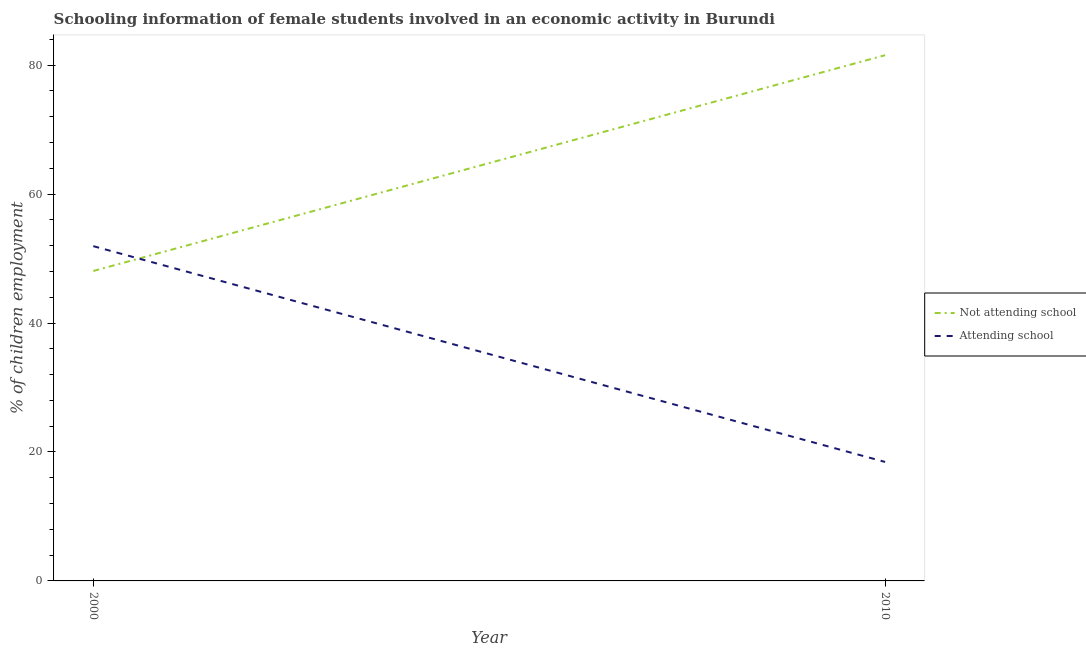How many different coloured lines are there?
Provide a succinct answer. 2. Does the line corresponding to percentage of employed females who are attending school intersect with the line corresponding to percentage of employed females who are not attending school?
Make the answer very short. Yes. Is the number of lines equal to the number of legend labels?
Your response must be concise. Yes. What is the percentage of employed females who are not attending school in 2010?
Provide a short and direct response. 81.54. Across all years, what is the maximum percentage of employed females who are attending school?
Your answer should be very brief. 51.93. Across all years, what is the minimum percentage of employed females who are attending school?
Your answer should be compact. 18.46. In which year was the percentage of employed females who are not attending school maximum?
Give a very brief answer. 2010. What is the total percentage of employed females who are attending school in the graph?
Offer a very short reply. 70.38. What is the difference between the percentage of employed females who are not attending school in 2000 and that in 2010?
Your response must be concise. -33.47. What is the difference between the percentage of employed females who are attending school in 2010 and the percentage of employed females who are not attending school in 2000?
Provide a short and direct response. -29.62. What is the average percentage of employed females who are attending school per year?
Ensure brevity in your answer.  35.19. In the year 2010, what is the difference between the percentage of employed females who are attending school and percentage of employed females who are not attending school?
Your answer should be compact. -63.09. What is the ratio of the percentage of employed females who are attending school in 2000 to that in 2010?
Make the answer very short. 2.81. Is the percentage of employed females who are attending school in 2000 less than that in 2010?
Give a very brief answer. No. Is the percentage of employed females who are attending school strictly greater than the percentage of employed females who are not attending school over the years?
Give a very brief answer. No. How many lines are there?
Keep it short and to the point. 2. How many years are there in the graph?
Offer a terse response. 2. Does the graph contain grids?
Your answer should be very brief. No. How are the legend labels stacked?
Provide a short and direct response. Vertical. What is the title of the graph?
Keep it short and to the point. Schooling information of female students involved in an economic activity in Burundi. What is the label or title of the X-axis?
Provide a short and direct response. Year. What is the label or title of the Y-axis?
Make the answer very short. % of children employment. What is the % of children employment in Not attending school in 2000?
Offer a terse response. 48.07. What is the % of children employment in Attending school in 2000?
Make the answer very short. 51.93. What is the % of children employment in Not attending school in 2010?
Ensure brevity in your answer.  81.54. What is the % of children employment in Attending school in 2010?
Your answer should be very brief. 18.46. Across all years, what is the maximum % of children employment of Not attending school?
Provide a short and direct response. 81.54. Across all years, what is the maximum % of children employment in Attending school?
Offer a very short reply. 51.93. Across all years, what is the minimum % of children employment in Not attending school?
Give a very brief answer. 48.07. Across all years, what is the minimum % of children employment in Attending school?
Offer a terse response. 18.46. What is the total % of children employment in Not attending school in the graph?
Offer a terse response. 129.62. What is the total % of children employment in Attending school in the graph?
Keep it short and to the point. 70.38. What is the difference between the % of children employment of Not attending school in 2000 and that in 2010?
Keep it short and to the point. -33.47. What is the difference between the % of children employment of Attending school in 2000 and that in 2010?
Give a very brief answer. 33.47. What is the difference between the % of children employment in Not attending school in 2000 and the % of children employment in Attending school in 2010?
Your answer should be compact. 29.62. What is the average % of children employment of Not attending school per year?
Keep it short and to the point. 64.81. What is the average % of children employment in Attending school per year?
Keep it short and to the point. 35.19. In the year 2000, what is the difference between the % of children employment in Not attending school and % of children employment in Attending school?
Provide a short and direct response. -3.85. In the year 2010, what is the difference between the % of children employment of Not attending school and % of children employment of Attending school?
Make the answer very short. 63.09. What is the ratio of the % of children employment of Not attending school in 2000 to that in 2010?
Your answer should be very brief. 0.59. What is the ratio of the % of children employment in Attending school in 2000 to that in 2010?
Make the answer very short. 2.81. What is the difference between the highest and the second highest % of children employment in Not attending school?
Make the answer very short. 33.47. What is the difference between the highest and the second highest % of children employment of Attending school?
Offer a terse response. 33.47. What is the difference between the highest and the lowest % of children employment of Not attending school?
Provide a succinct answer. 33.47. What is the difference between the highest and the lowest % of children employment of Attending school?
Offer a very short reply. 33.47. 